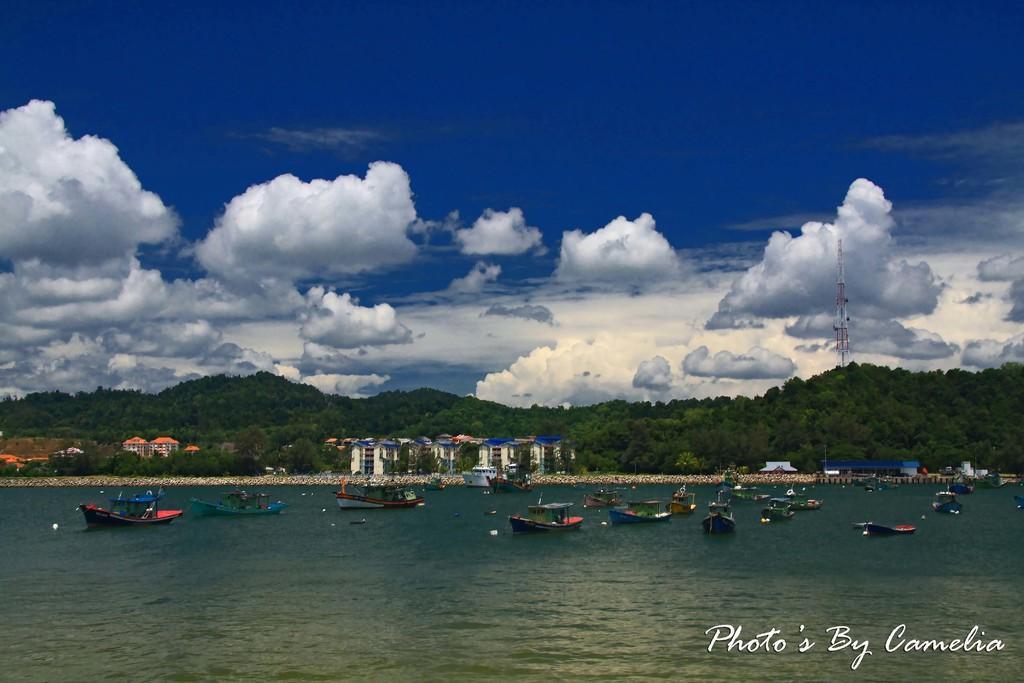Can you describe this image briefly? In the picture I can see boats on the water. In the background I can see buildings, trees, a tower and the sky. On the bottom right corner of the image I can see a watermark. 